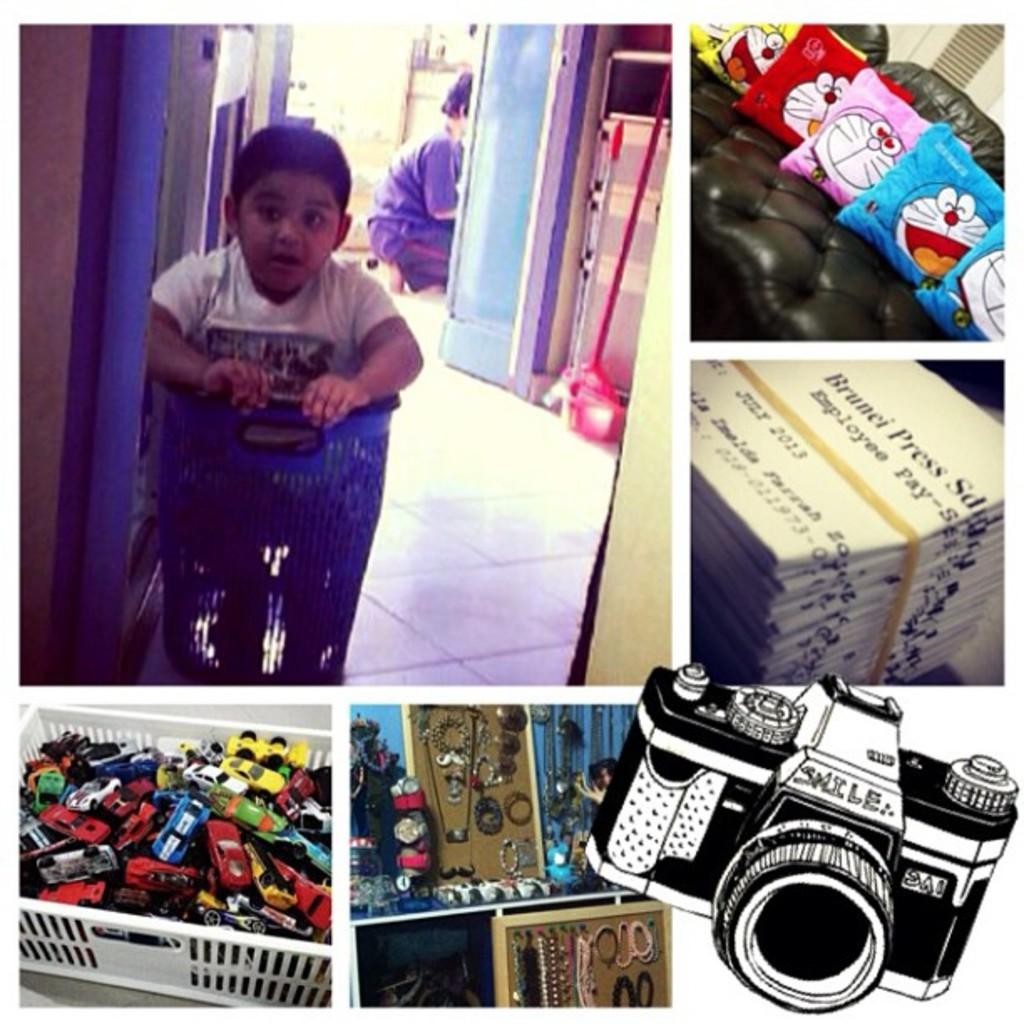What is the main subject of the image? The main subject of the image is a collage. What can be found within the collage? The collage contains pictures, including two persons, toy cars, a couch, and cushions. Are there any other items in the collage? Yes, there is a picture of a camera and other objects in the collage. What type of education can be seen in the image? There is no reference to education in the image; it features a collage with various pictures and objects. Can you describe the coastline visible in the image? There is no coastline present in the image; it is a collage with pictures and objects. 